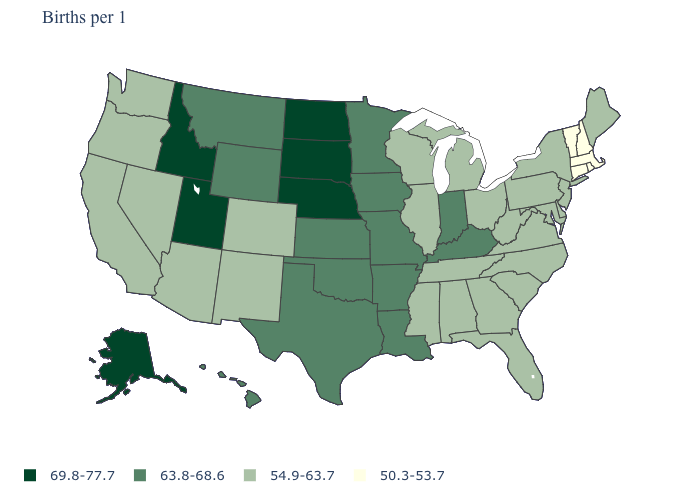Name the states that have a value in the range 69.8-77.7?
Quick response, please. Alaska, Idaho, Nebraska, North Dakota, South Dakota, Utah. What is the value of West Virginia?
Answer briefly. 54.9-63.7. What is the value of New Jersey?
Concise answer only. 54.9-63.7. Name the states that have a value in the range 50.3-53.7?
Answer briefly. Connecticut, Massachusetts, New Hampshire, Rhode Island, Vermont. Does Tennessee have the same value as Arkansas?
Write a very short answer. No. Does Montana have the lowest value in the West?
Write a very short answer. No. Name the states that have a value in the range 50.3-53.7?
Keep it brief. Connecticut, Massachusetts, New Hampshire, Rhode Island, Vermont. Name the states that have a value in the range 50.3-53.7?
Be succinct. Connecticut, Massachusetts, New Hampshire, Rhode Island, Vermont. What is the lowest value in the MidWest?
Write a very short answer. 54.9-63.7. What is the value of Connecticut?
Concise answer only. 50.3-53.7. Does Maine have a higher value than Massachusetts?
Concise answer only. Yes. Does Nevada have the lowest value in the West?
Give a very brief answer. Yes. Name the states that have a value in the range 54.9-63.7?
Write a very short answer. Alabama, Arizona, California, Colorado, Delaware, Florida, Georgia, Illinois, Maine, Maryland, Michigan, Mississippi, Nevada, New Jersey, New Mexico, New York, North Carolina, Ohio, Oregon, Pennsylvania, South Carolina, Tennessee, Virginia, Washington, West Virginia, Wisconsin. What is the lowest value in the Northeast?
Give a very brief answer. 50.3-53.7. 